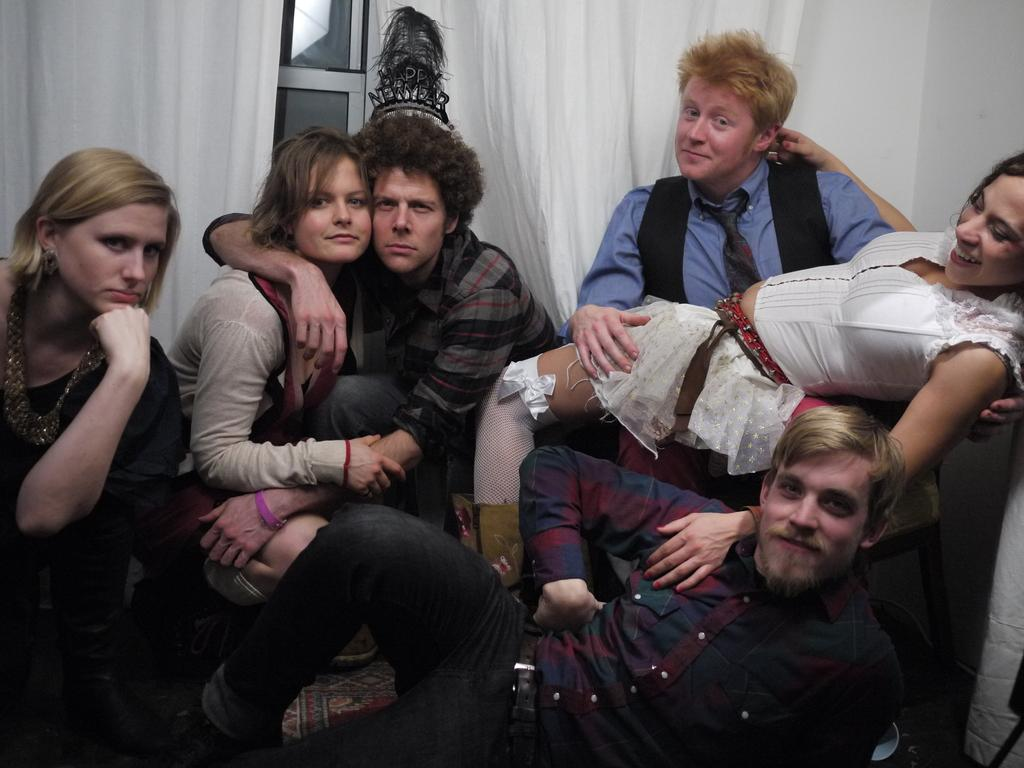What are the people in the image doing? There are many persons sitting on the ground in the image. What can be seen in the background of the image? There is a window and a wall in the background of the image. What type of window treatment is present in the image? There are curtains associated with the window in the background of the image. What type of instrument is being played by the person standing on their feet in the image? There is no person standing on their feet playing an instrument in the image; all the persons are sitting on the ground. 